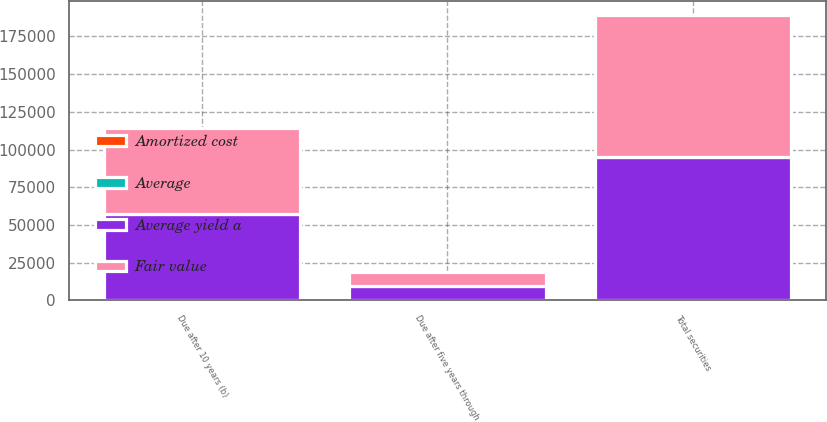Convert chart to OTSL. <chart><loc_0><loc_0><loc_500><loc_500><stacked_bar_chart><ecel><fcel>Due after five years through<fcel>Due after 10 years (b)<fcel>Total securities<nl><fcel>Average yield a<fcel>9270<fcel>57270<fcel>94821<nl><fcel>Fair value<fcel>9278<fcel>56880<fcel>94402<nl><fcel>Average<fcel>3.77<fcel>4.48<fcel>3.95<nl><fcel>Amortized cost<fcel>16<fcel>101<fcel>117<nl></chart> 